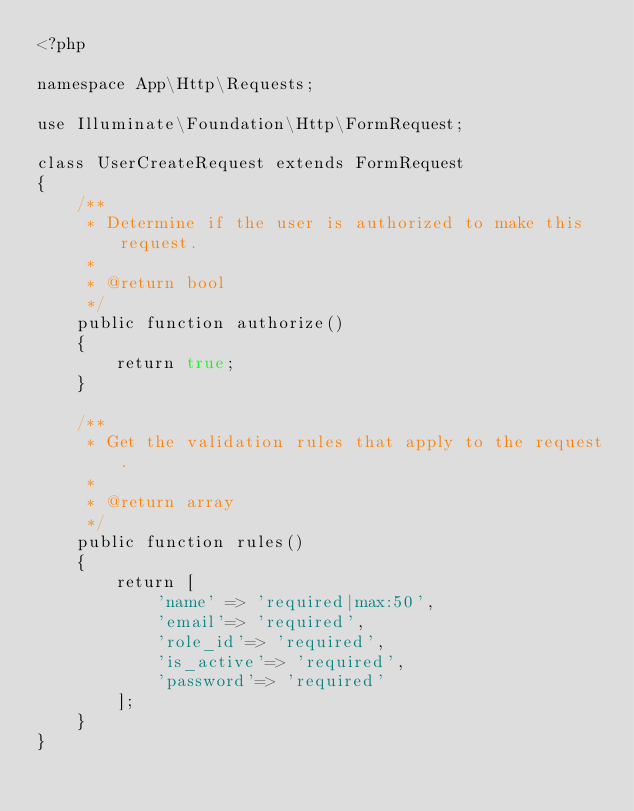Convert code to text. <code><loc_0><loc_0><loc_500><loc_500><_PHP_><?php

namespace App\Http\Requests;

use Illuminate\Foundation\Http\FormRequest;

class UserCreateRequest extends FormRequest
{
    /**
     * Determine if the user is authorized to make this request.
     *
     * @return bool
     */
    public function authorize()
    {
        return true;
    }

    /**
     * Get the validation rules that apply to the request.
     *
     * @return array
     */
    public function rules()
    {
        return [
            'name' => 'required|max:50',
            'email'=> 'required',
            'role_id'=> 'required',
            'is_active'=> 'required',
            'password'=> 'required'
        ];
    }
}
</code> 